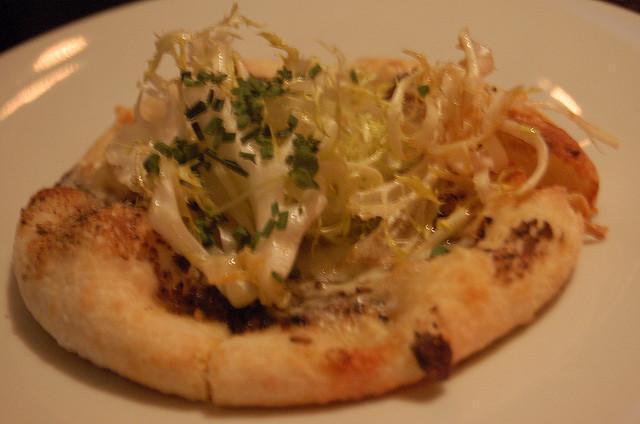How many people are standing under umbrella?
Give a very brief answer. 0. 